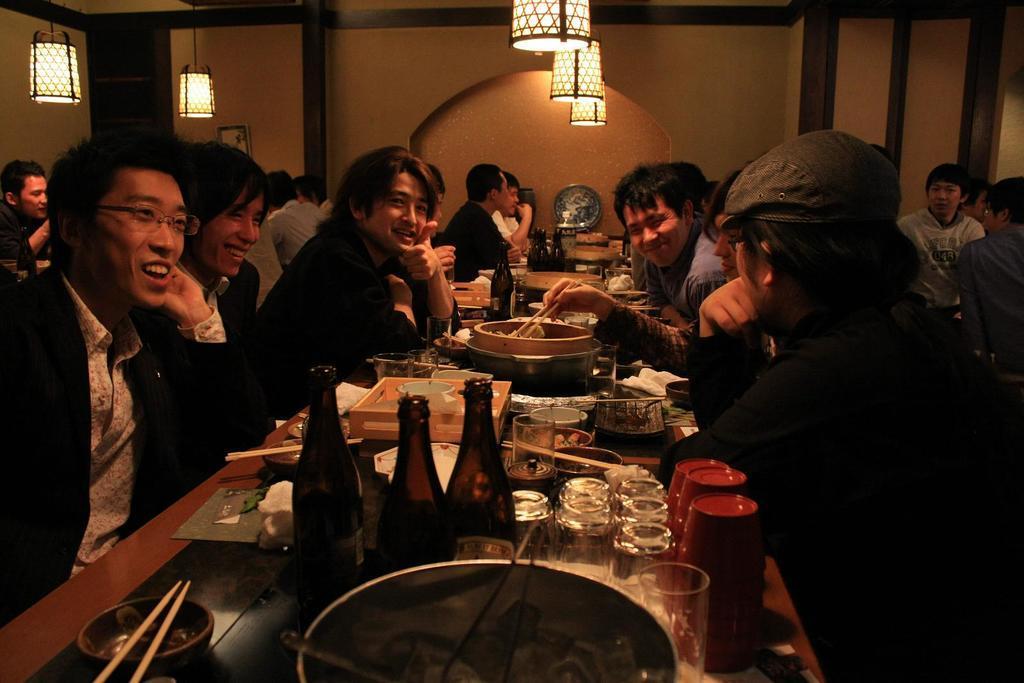Please provide a concise description of this image. In this image I can see number of people are sitting. I can also see smile on few faces. Here I can see he is wearing a cap and he is wearing a specs. On this table I can see few bottles, few glasses and food. I can also see few more tables and few more bottles. Here I can see few lights and a frame on this wall. 